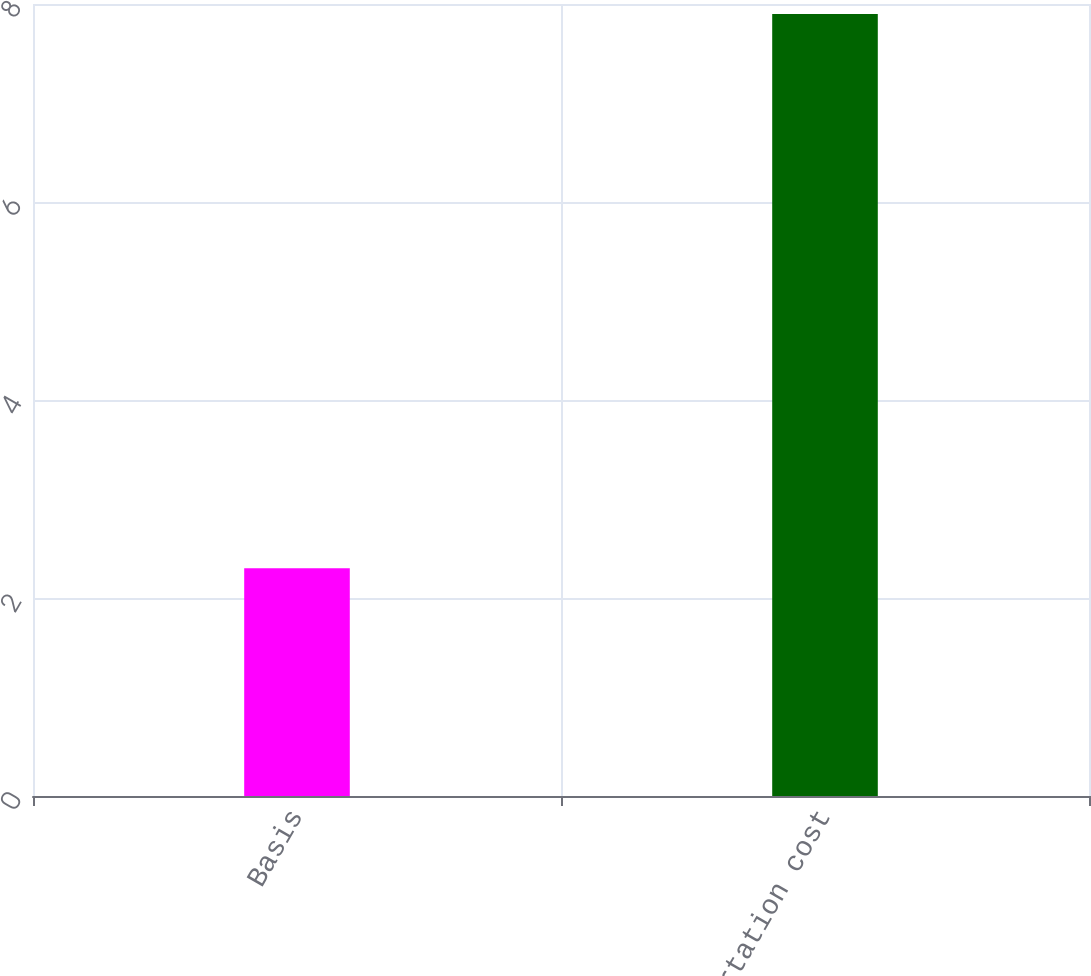Convert chart. <chart><loc_0><loc_0><loc_500><loc_500><bar_chart><fcel>Basis<fcel>Transportation cost<nl><fcel>2.3<fcel>7.9<nl></chart> 